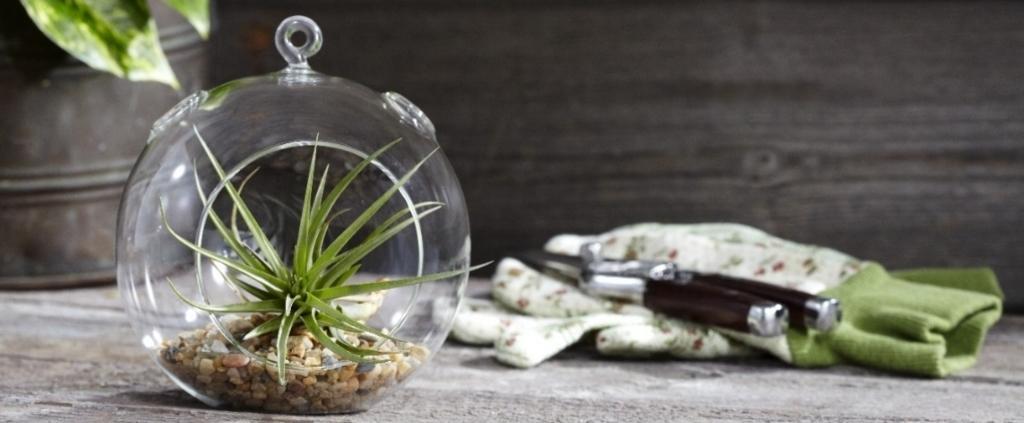Could you give a brief overview of what you see in this image? In the middle of the image we can see some plants. Behind the plant there is a cloth, on the cloth there is something. 